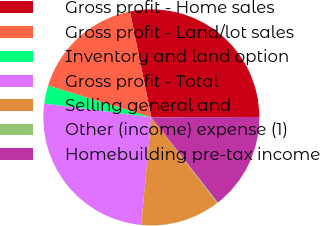Convert chart to OTSL. <chart><loc_0><loc_0><loc_500><loc_500><pie_chart><fcel>Gross profit - Home sales<fcel>Gross profit - Land/lot sales<fcel>Inventory and land option<fcel>Gross profit - Total<fcel>Selling general and<fcel>Other (income) expense (1)<fcel>Homebuilding pre-tax income<nl><fcel>28.11%<fcel>17.09%<fcel>2.71%<fcel>25.53%<fcel>11.93%<fcel>0.13%<fcel>14.51%<nl></chart> 